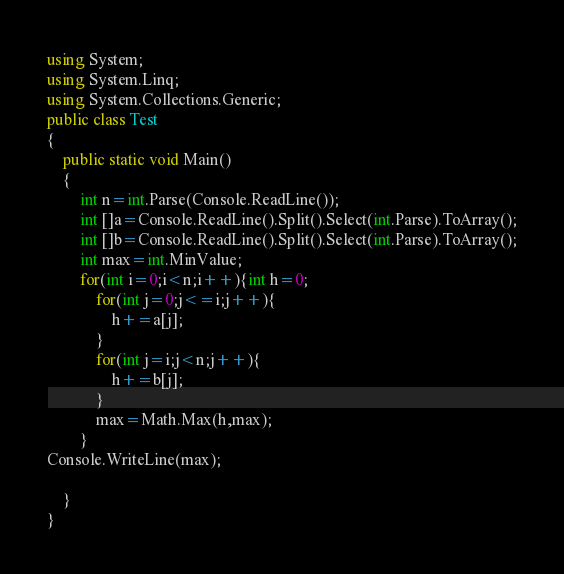<code> <loc_0><loc_0><loc_500><loc_500><_C#_>using System;
using System.Linq;
using System.Collections.Generic;
public class Test
{
	public static void Main()
	{
		int n=int.Parse(Console.ReadLine());
		int []a=Console.ReadLine().Split().Select(int.Parse).ToArray();
		int []b=Console.ReadLine().Split().Select(int.Parse).ToArray();
		int max=int.MinValue;
		for(int i=0;i<n;i++){int h=0;
			for(int j=0;j<=i;j++){
				h+=a[j];
			}
			for(int j=i;j<n;j++){
				h+=b[j];
			}
			max=Math.Max(h,max);
		}
Console.WriteLine(max);
		
	}
}</code> 